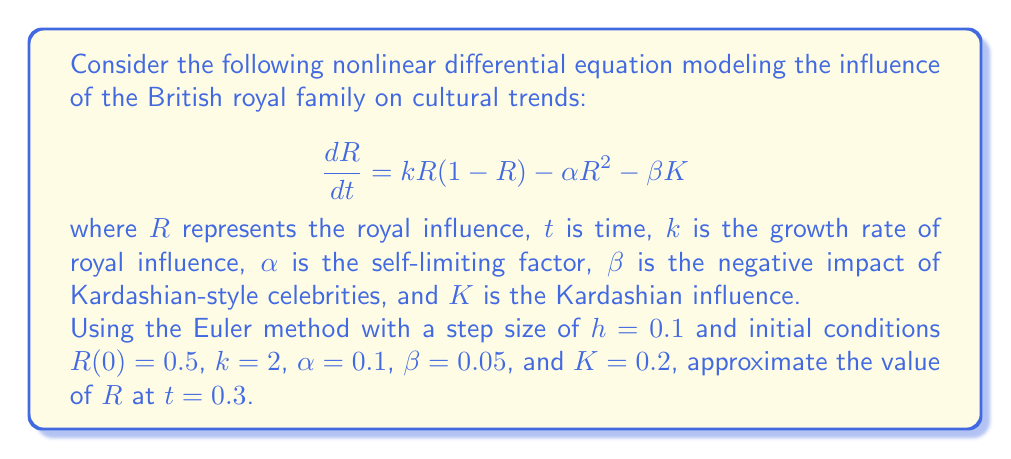Can you solve this math problem? To solve this problem using the Euler method, we'll follow these steps:

1) The Euler method formula is:
   $$R_{n+1} = R_n + h \cdot f(t_n, R_n)$$
   where $f(t, R) = kR(1-R) - \alpha R^2 - \beta K$

2) We're given:
   $h = 0.1$, $R_0 = 0.5$, $k = 2$, $\alpha = 0.1$, $\beta = 0.05$, $K = 0.2$

3) We need to calculate $R_1$, $R_2$, and $R_3$ to reach $t = 0.3$

4) For $R_1$ (t = 0.1):
   $$\begin{align*}
   f(0, 0.5) &= 2(0.5)(1-0.5) - 0.1(0.5)^2 - 0.05(0.2) \\
             &= 0.5 - 0.025 - 0.01 = 0.465
   \end{align*}$$
   $$R_1 = 0.5 + 0.1(0.465) = 0.5465$$

5) For $R_2$ (t = 0.2):
   $$\begin{align*}
   f(0.1, 0.5465) &= 2(0.5465)(1-0.5465) - 0.1(0.5465)^2 - 0.05(0.2) \\
                  &= 0.4960 - 0.0299 - 0.01 = 0.4561
   \end{align*}$$
   $$R_2 = 0.5465 + 0.1(0.4561) = 0.5921$$

6) For $R_3$ (t = 0.3):
   $$\begin{align*}
   f(0.2, 0.5921) &= 2(0.5921)(1-0.5921) - 0.1(0.5921)^2 - 0.05(0.2) \\
                  &= 0.4833 - 0.0351 - 0.01 = 0.4382
   \end{align*}$$
   $$R_3 = 0.5921 + 0.1(0.4382) = 0.6359$$

Therefore, the approximated value of $R$ at $t = 0.3$ is 0.6359.
Answer: 0.6359 